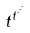Convert formula to latex. <formula><loc_0><loc_0><loc_500><loc_500>t ^ { t ^ { \cdot ^ { \cdot ^ { \cdot } } } }</formula> 